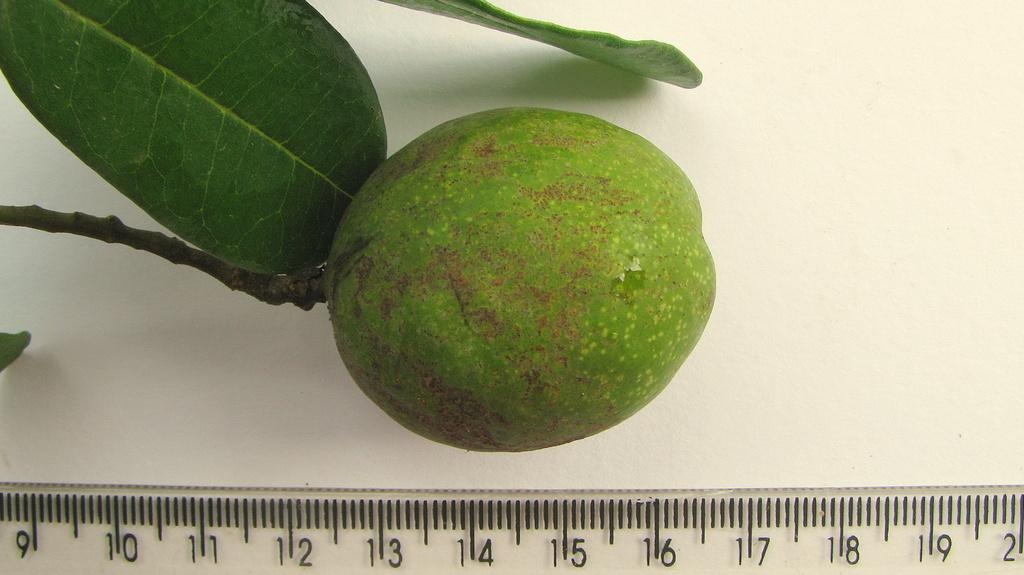What type of fruit is visible in the image? There is a fruit in the image, but the specific type cannot be determined from the facts provided. What else can be seen in the image besides the fruit? There are leaves and a stem visible in the image. What might be used to measure the size or weight of the fruit? There is a measuring scale in the image. What color is the background of the image? The background of the image is white. What type of beast is present in the image? There is no beast present in the image; it features a fruit, leaves, a stem, and a measuring scale. What advice might the grandfather give about the fruit in the image? There is no grandfather present in the image, so it is not possible to determine what advice he might give. 